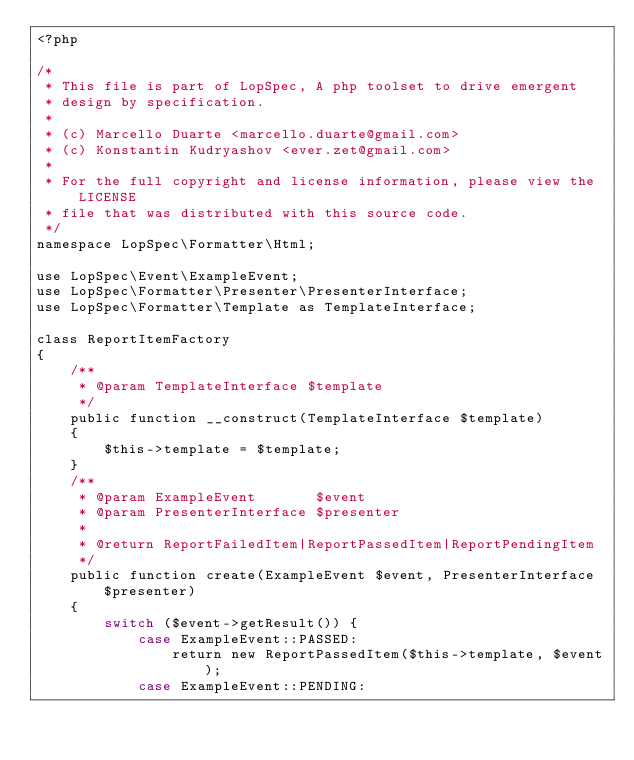<code> <loc_0><loc_0><loc_500><loc_500><_PHP_><?php

/*
 * This file is part of LopSpec, A php toolset to drive emergent
 * design by specification.
 *
 * (c) Marcello Duarte <marcello.duarte@gmail.com>
 * (c) Konstantin Kudryashov <ever.zet@gmail.com>
 *
 * For the full copyright and license information, please view the LICENSE
 * file that was distributed with this source code.
 */
namespace LopSpec\Formatter\Html;

use LopSpec\Event\ExampleEvent;
use LopSpec\Formatter\Presenter\PresenterInterface;
use LopSpec\Formatter\Template as TemplateInterface;

class ReportItemFactory
{
    /**
     * @param TemplateInterface $template
     */
    public function __construct(TemplateInterface $template)
    {
        $this->template = $template;
    }
    /**
     * @param ExampleEvent       $event
     * @param PresenterInterface $presenter
     *
     * @return ReportFailedItem|ReportPassedItem|ReportPendingItem
     */
    public function create(ExampleEvent $event, PresenterInterface $presenter)
    {
        switch ($event->getResult()) {
            case ExampleEvent::PASSED:
                return new ReportPassedItem($this->template, $event);
            case ExampleEvent::PENDING:</code> 